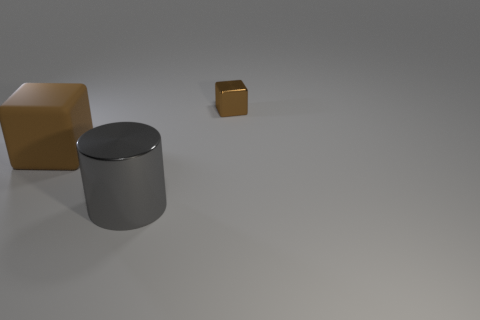Add 3 large red shiny objects. How many objects exist? 6 Subtract 2 cubes. How many cubes are left? 0 Subtract all purple cylinders. Subtract all blue cubes. How many cylinders are left? 1 Subtract all yellow cubes. How many yellow cylinders are left? 0 Subtract all large brown objects. Subtract all shiny things. How many objects are left? 0 Add 1 tiny things. How many tiny things are left? 2 Add 1 small metallic objects. How many small metallic objects exist? 2 Subtract 0 cyan cubes. How many objects are left? 3 Subtract all blocks. How many objects are left? 1 